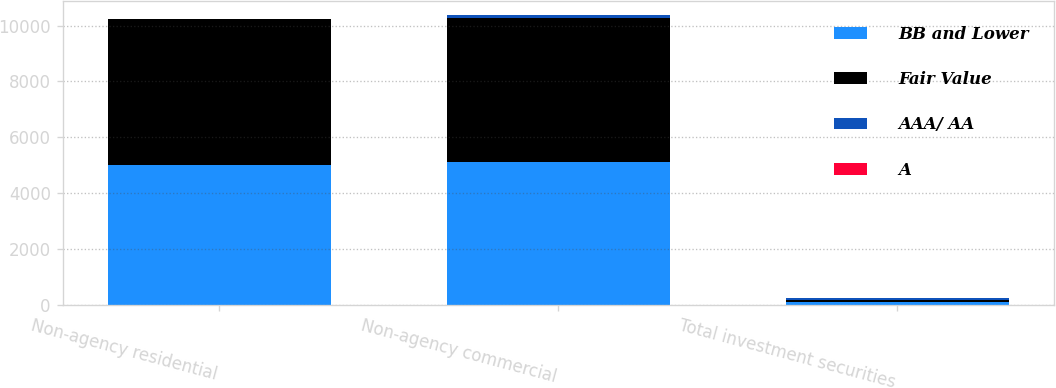Convert chart. <chart><loc_0><loc_0><loc_500><loc_500><stacked_bar_chart><ecel><fcel>Non-agency residential<fcel>Non-agency commercial<fcel>Total investment securities<nl><fcel>BB and Lower<fcel>4993<fcel>5095<fcel>81<nl><fcel>Fair Value<fcel>5225<fcel>5191<fcel>81<nl><fcel>AAA/ AA<fcel>10<fcel>77<fcel>85<nl><fcel>A<fcel>1<fcel>7<fcel>2<nl></chart> 